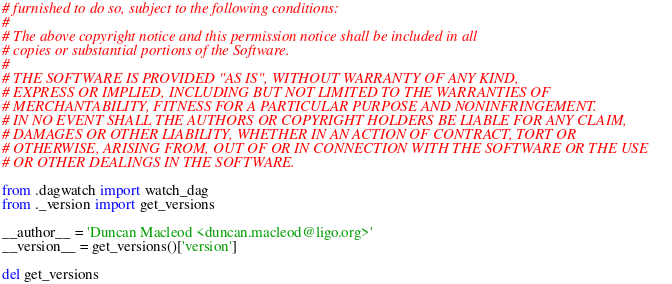Convert code to text. <code><loc_0><loc_0><loc_500><loc_500><_Python_># furnished to do so, subject to the following conditions:
#
# The above copyright notice and this permission notice shall be included in all
# copies or substantial portions of the Software.
#
# THE SOFTWARE IS PROVIDED "AS IS", WITHOUT WARRANTY OF ANY KIND,
# EXPRESS OR IMPLIED, INCLUDING BUT NOT LIMITED TO THE WARRANTIES OF
# MERCHANTABILITY, FITNESS FOR A PARTICULAR PURPOSE AND NONINFRINGEMENT.
# IN NO EVENT SHALL THE AUTHORS OR COPYRIGHT HOLDERS BE LIABLE FOR ANY CLAIM,
# DAMAGES OR OTHER LIABILITY, WHETHER IN AN ACTION OF CONTRACT, TORT OR
# OTHERWISE, ARISING FROM, OUT OF OR IN CONNECTION WITH THE SOFTWARE OR THE USE
# OR OTHER DEALINGS IN THE SOFTWARE.

from .dagwatch import watch_dag
from ._version import get_versions

__author__ = 'Duncan Macleod <duncan.macleod@ligo.org>'
__version__ = get_versions()['version']

del get_versions
</code> 